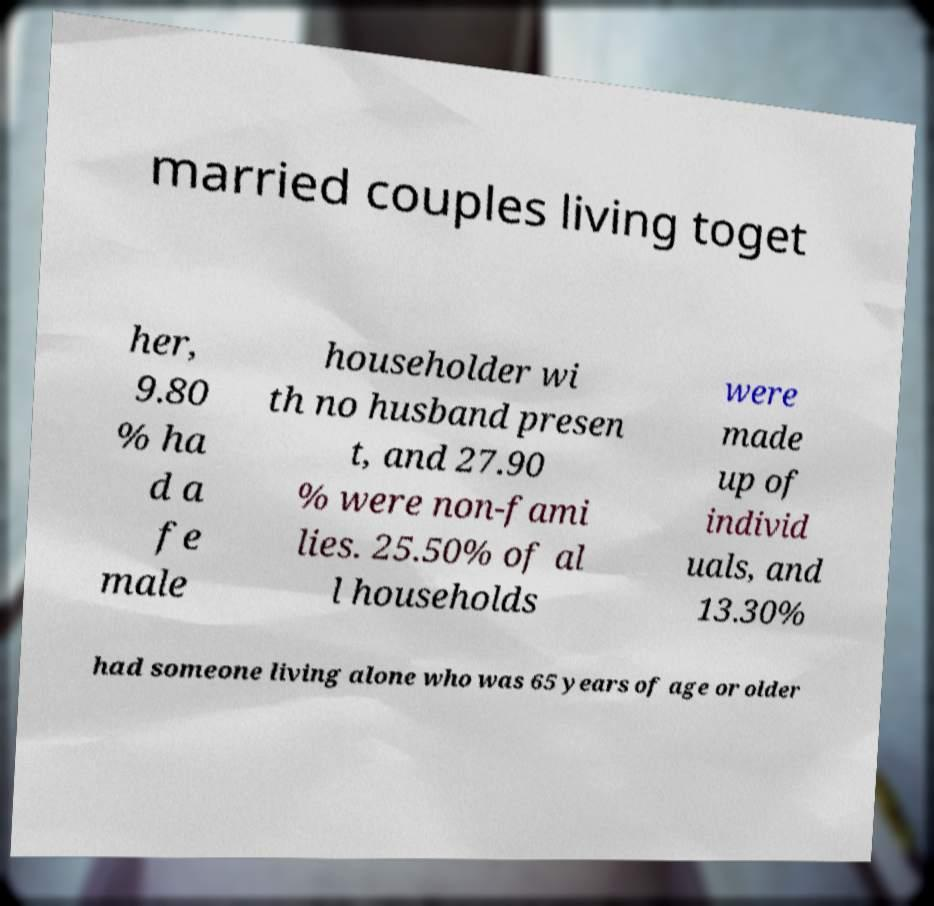Please read and relay the text visible in this image. What does it say? married couples living toget her, 9.80 % ha d a fe male householder wi th no husband presen t, and 27.90 % were non-fami lies. 25.50% of al l households were made up of individ uals, and 13.30% had someone living alone who was 65 years of age or older 